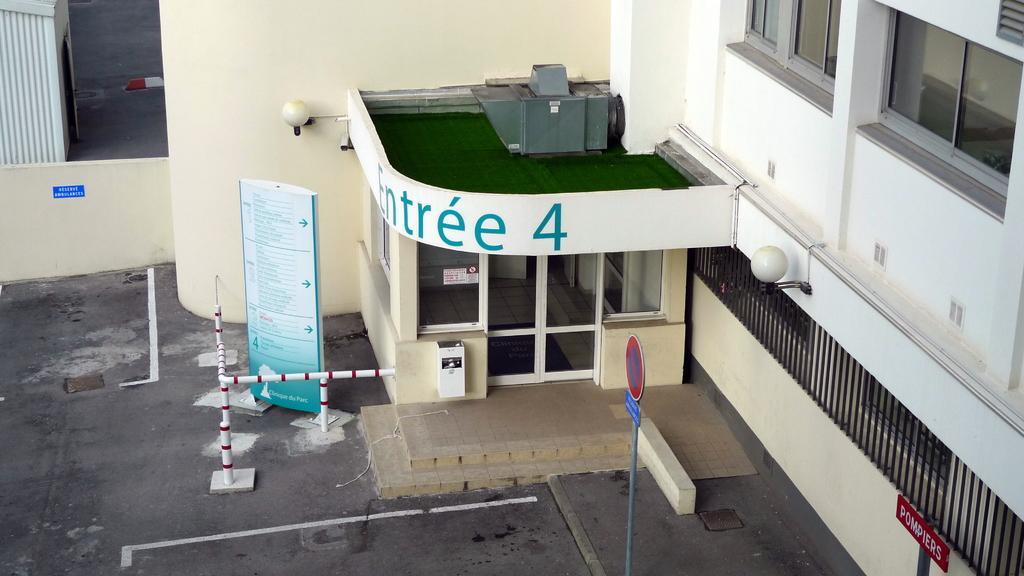Can you describe this image briefly? In this image we can see the building, glass door and also windows and lights and also the house. We can also see the sign board, informational board, barrier, wall and also the text boards. We can also see the path. 